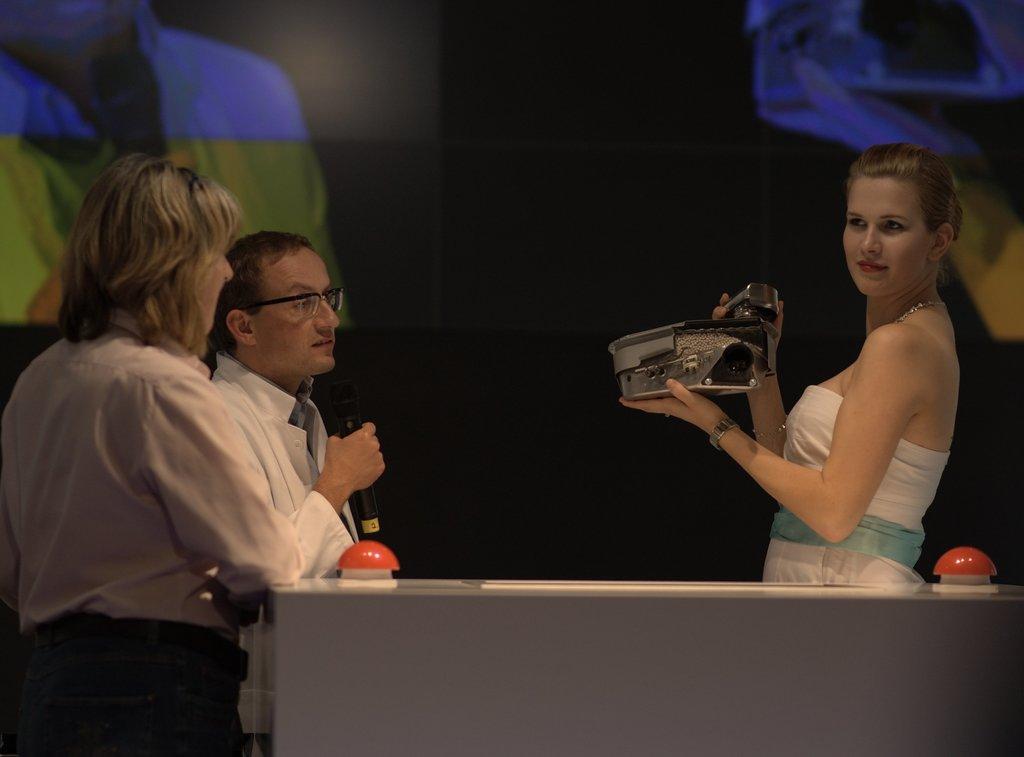Can you describe this image briefly? In this image there are three persons. The man is holding a mic and woman is holding something. At the background we can see a screen. 